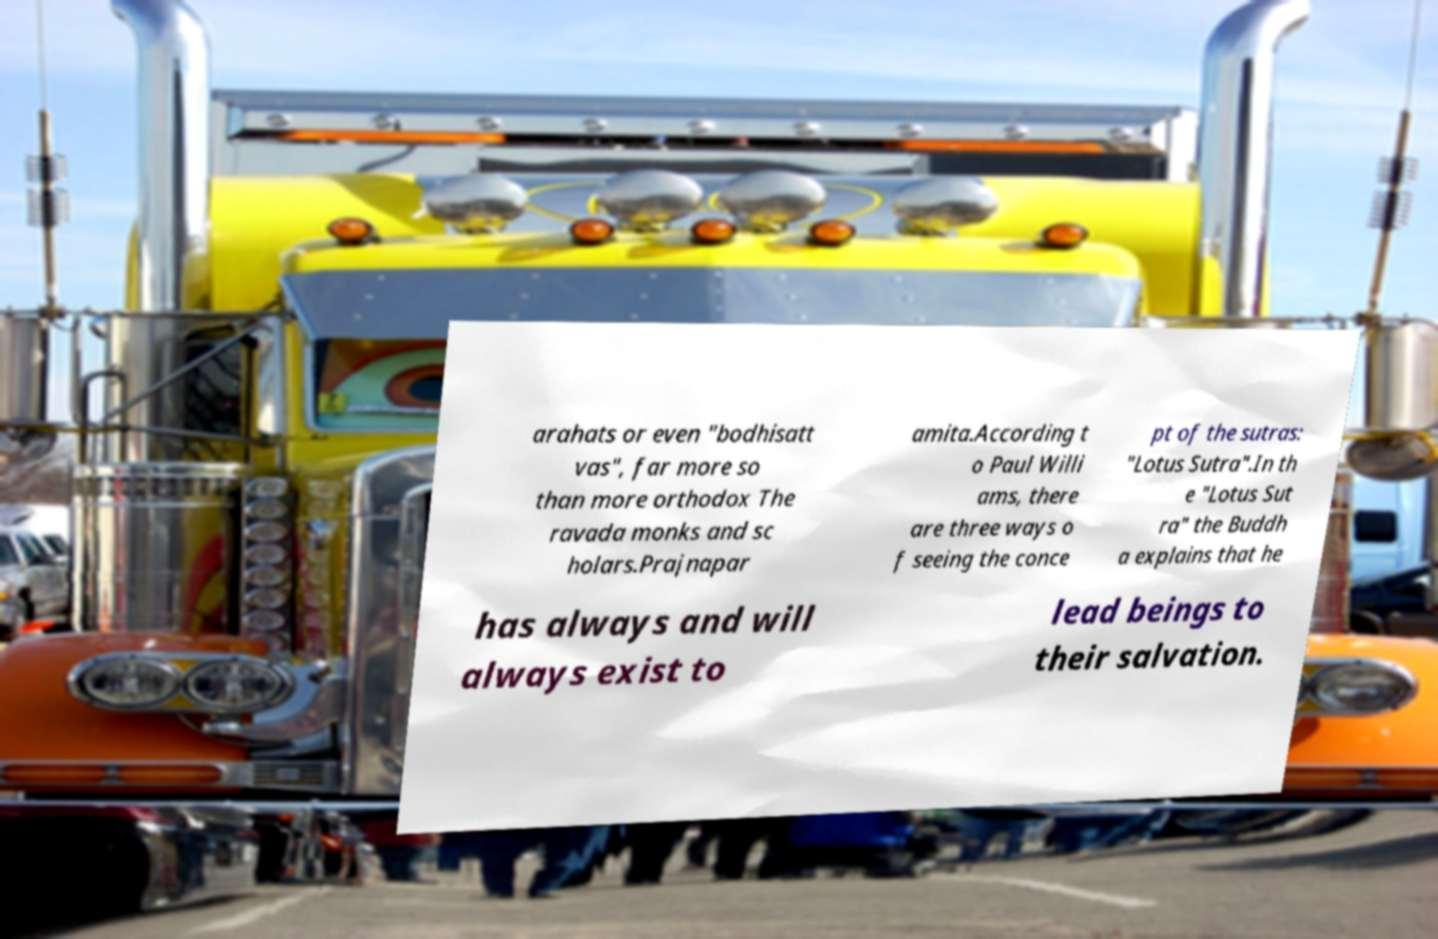Could you extract and type out the text from this image? arahats or even "bodhisatt vas", far more so than more orthodox The ravada monks and sc holars.Prajnapar amita.According t o Paul Willi ams, there are three ways o f seeing the conce pt of the sutras: "Lotus Sutra".In th e "Lotus Sut ra" the Buddh a explains that he has always and will always exist to lead beings to their salvation. 